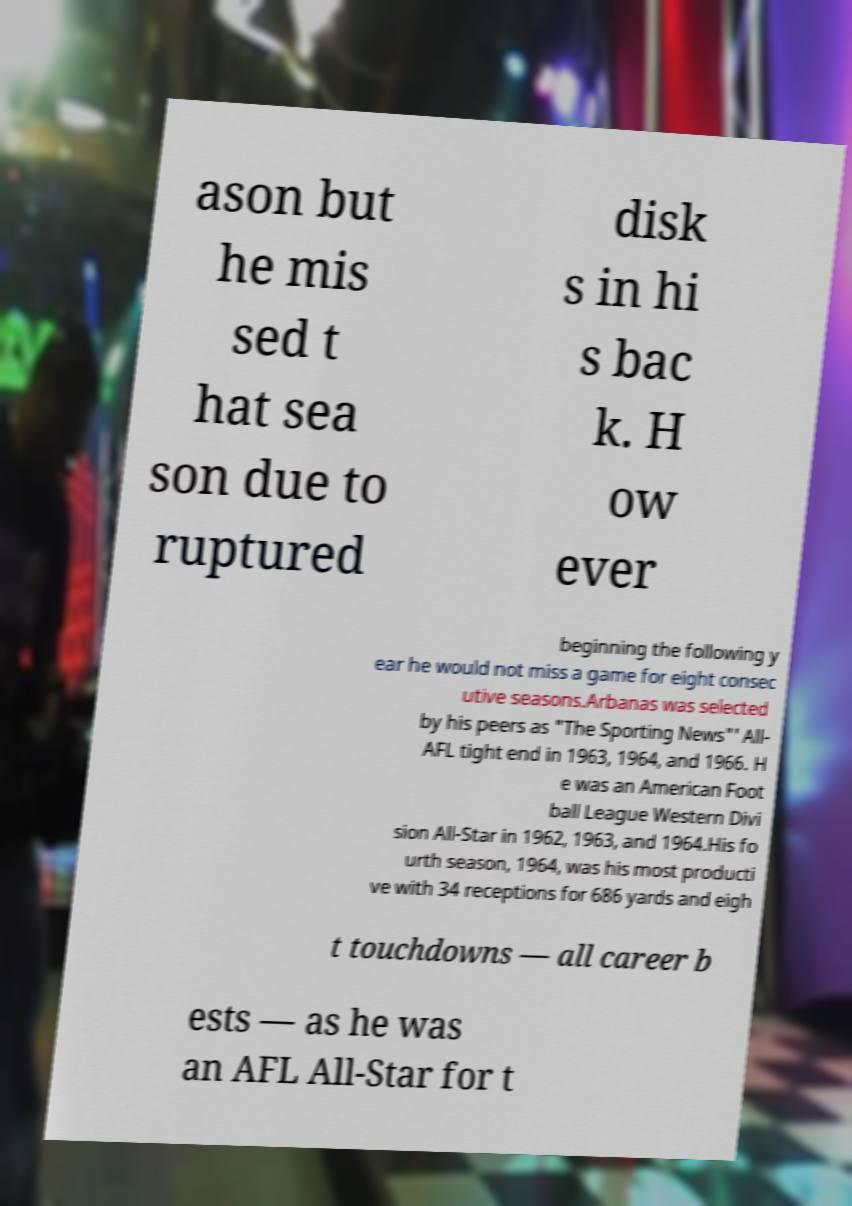For documentation purposes, I need the text within this image transcribed. Could you provide that? ason but he mis sed t hat sea son due to ruptured disk s in hi s bac k. H ow ever beginning the following y ear he would not miss a game for eight consec utive seasons.Arbanas was selected by his peers as "The Sporting News"' All- AFL tight end in 1963, 1964, and 1966. H e was an American Foot ball League Western Divi sion All-Star in 1962, 1963, and 1964.His fo urth season, 1964, was his most producti ve with 34 receptions for 686 yards and eigh t touchdowns — all career b ests — as he was an AFL All-Star for t 